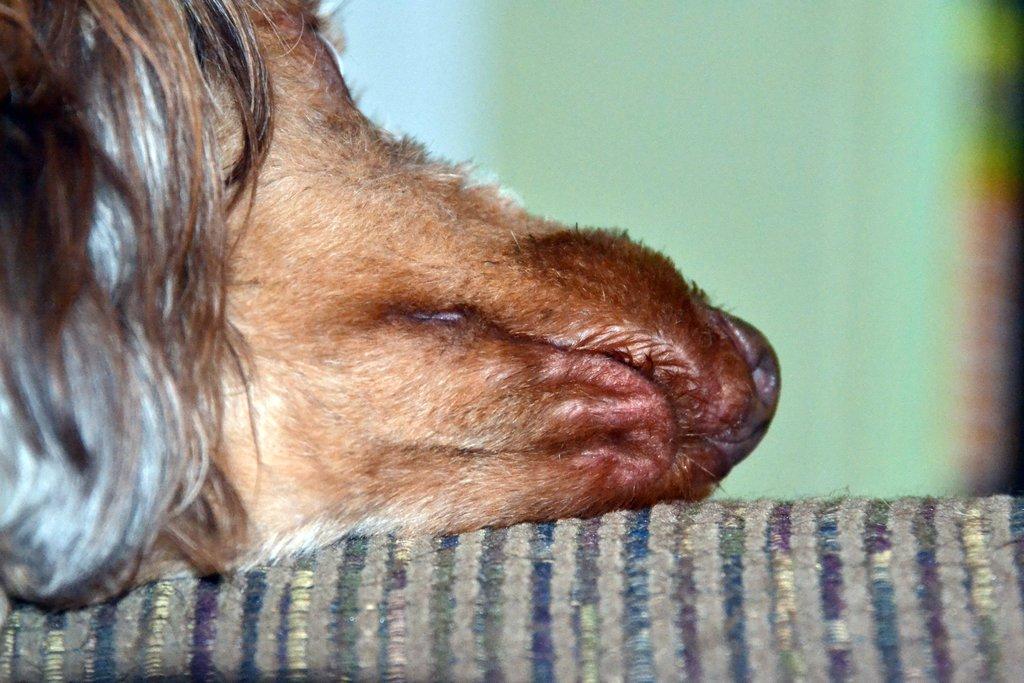Could you give a brief overview of what you see in this image? In this image there is an animal face on the cloth, and there is blur background. 